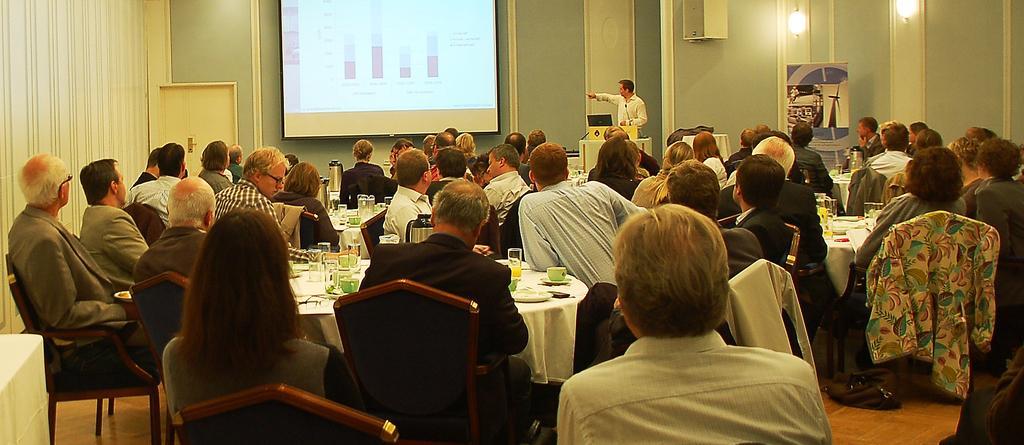Can you describe this image briefly? There is a room. There is a group of people. They are sitting on a chairs. In the center we have a person. He is standing and He is wearing a tie. There is a table. There is a glass,flask,cup,saucer,fork on a table. We can see in background wall,curtain and projector. 